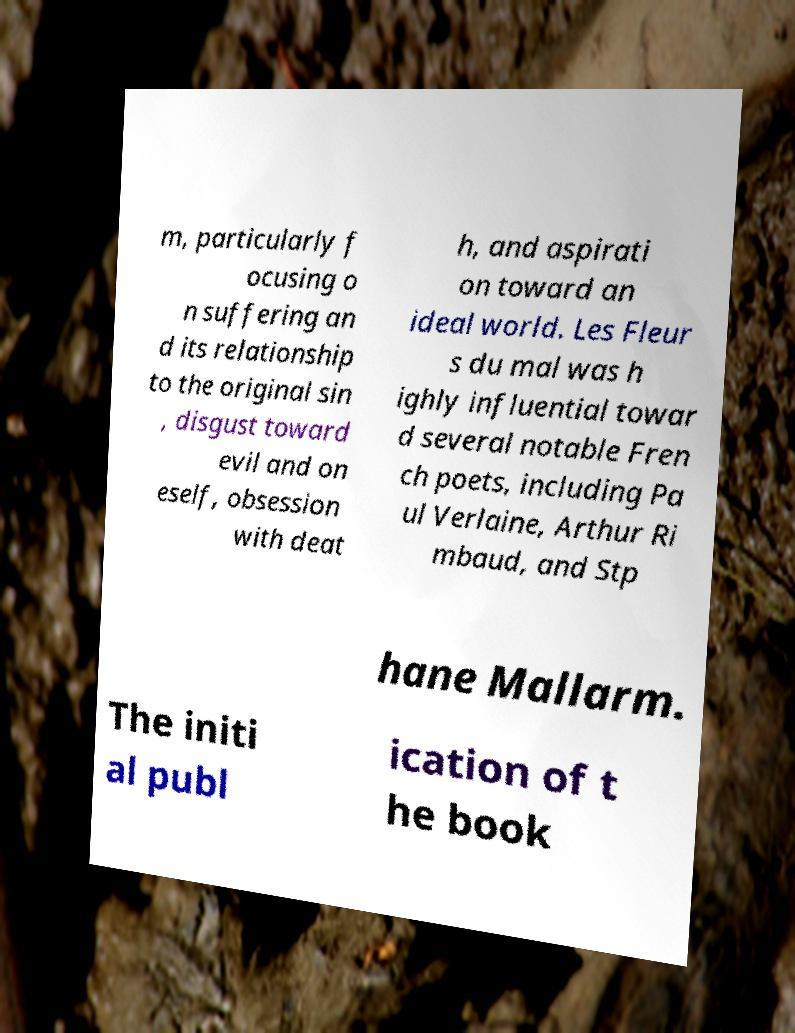What messages or text are displayed in this image? I need them in a readable, typed format. m, particularly f ocusing o n suffering an d its relationship to the original sin , disgust toward evil and on eself, obsession with deat h, and aspirati on toward an ideal world. Les Fleur s du mal was h ighly influential towar d several notable Fren ch poets, including Pa ul Verlaine, Arthur Ri mbaud, and Stp hane Mallarm. The initi al publ ication of t he book 